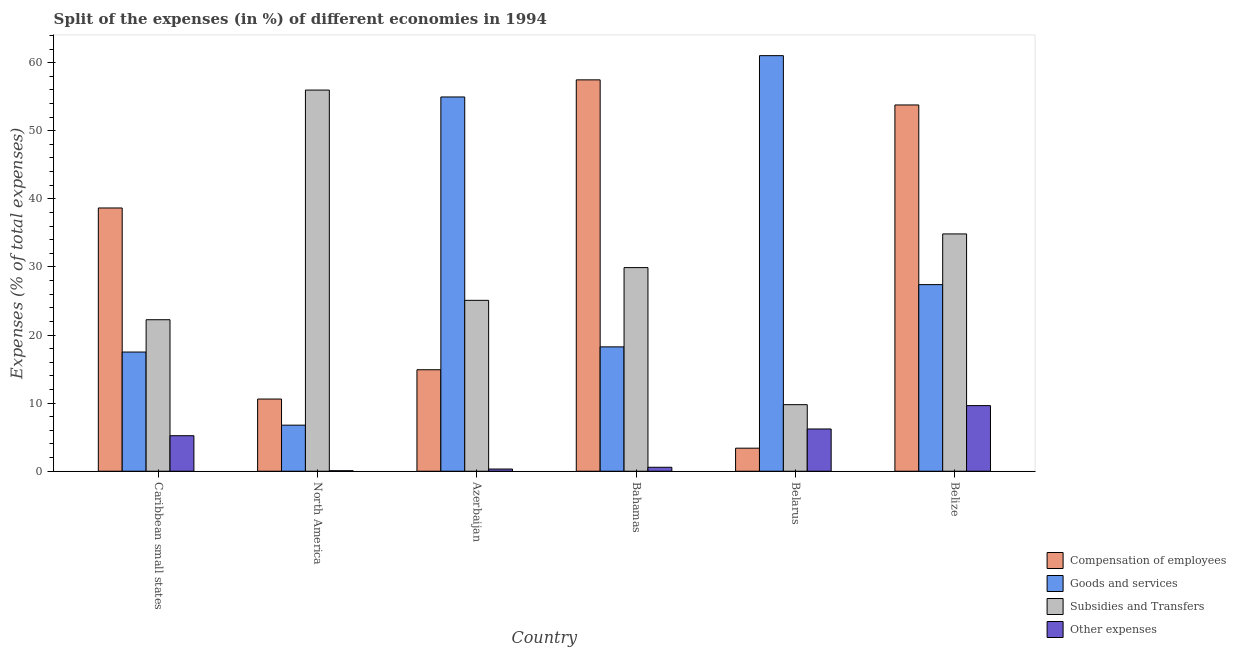How many bars are there on the 2nd tick from the left?
Your answer should be very brief. 4. What is the label of the 3rd group of bars from the left?
Your answer should be compact. Azerbaijan. What is the percentage of amount spent on subsidies in Caribbean small states?
Make the answer very short. 22.25. Across all countries, what is the maximum percentage of amount spent on subsidies?
Keep it short and to the point. 55.98. Across all countries, what is the minimum percentage of amount spent on other expenses?
Your response must be concise. 0.07. In which country was the percentage of amount spent on compensation of employees maximum?
Provide a short and direct response. Bahamas. In which country was the percentage of amount spent on subsidies minimum?
Ensure brevity in your answer.  Belarus. What is the total percentage of amount spent on goods and services in the graph?
Keep it short and to the point. 185.93. What is the difference between the percentage of amount spent on goods and services in Azerbaijan and that in Belize?
Your answer should be compact. 27.56. What is the difference between the percentage of amount spent on goods and services in Azerbaijan and the percentage of amount spent on compensation of employees in North America?
Provide a succinct answer. 44.36. What is the average percentage of amount spent on goods and services per country?
Keep it short and to the point. 30.99. What is the difference between the percentage of amount spent on other expenses and percentage of amount spent on compensation of employees in North America?
Offer a very short reply. -10.53. In how many countries, is the percentage of amount spent on other expenses greater than 54 %?
Make the answer very short. 0. What is the ratio of the percentage of amount spent on compensation of employees in Bahamas to that in Belarus?
Your answer should be very brief. 16.97. Is the difference between the percentage of amount spent on subsidies in Caribbean small states and North America greater than the difference between the percentage of amount spent on goods and services in Caribbean small states and North America?
Offer a terse response. No. What is the difference between the highest and the second highest percentage of amount spent on compensation of employees?
Keep it short and to the point. 3.69. What is the difference between the highest and the lowest percentage of amount spent on compensation of employees?
Make the answer very short. 54.09. In how many countries, is the percentage of amount spent on other expenses greater than the average percentage of amount spent on other expenses taken over all countries?
Offer a very short reply. 3. What does the 1st bar from the left in Bahamas represents?
Provide a short and direct response. Compensation of employees. What does the 3rd bar from the right in North America represents?
Keep it short and to the point. Goods and services. Is it the case that in every country, the sum of the percentage of amount spent on compensation of employees and percentage of amount spent on goods and services is greater than the percentage of amount spent on subsidies?
Ensure brevity in your answer.  No. How many bars are there?
Offer a terse response. 24. What is the difference between two consecutive major ticks on the Y-axis?
Your response must be concise. 10. Does the graph contain any zero values?
Keep it short and to the point. No. Does the graph contain grids?
Offer a terse response. No. How many legend labels are there?
Your answer should be compact. 4. How are the legend labels stacked?
Offer a very short reply. Vertical. What is the title of the graph?
Offer a very short reply. Split of the expenses (in %) of different economies in 1994. Does "Services" appear as one of the legend labels in the graph?
Provide a short and direct response. No. What is the label or title of the Y-axis?
Offer a very short reply. Expenses (% of total expenses). What is the Expenses (% of total expenses) of Compensation of employees in Caribbean small states?
Your answer should be compact. 38.66. What is the Expenses (% of total expenses) in Goods and services in Caribbean small states?
Your response must be concise. 17.5. What is the Expenses (% of total expenses) of Subsidies and Transfers in Caribbean small states?
Ensure brevity in your answer.  22.25. What is the Expenses (% of total expenses) of Other expenses in Caribbean small states?
Give a very brief answer. 5.22. What is the Expenses (% of total expenses) of Compensation of employees in North America?
Your answer should be compact. 10.6. What is the Expenses (% of total expenses) in Goods and services in North America?
Your answer should be very brief. 6.77. What is the Expenses (% of total expenses) in Subsidies and Transfers in North America?
Make the answer very short. 55.98. What is the Expenses (% of total expenses) of Other expenses in North America?
Provide a short and direct response. 0.07. What is the Expenses (% of total expenses) of Compensation of employees in Azerbaijan?
Your answer should be very brief. 14.9. What is the Expenses (% of total expenses) of Goods and services in Azerbaijan?
Give a very brief answer. 54.96. What is the Expenses (% of total expenses) of Subsidies and Transfers in Azerbaijan?
Your answer should be very brief. 25.1. What is the Expenses (% of total expenses) in Other expenses in Azerbaijan?
Your answer should be very brief. 0.32. What is the Expenses (% of total expenses) in Compensation of employees in Bahamas?
Offer a terse response. 57.48. What is the Expenses (% of total expenses) in Goods and services in Bahamas?
Provide a short and direct response. 18.26. What is the Expenses (% of total expenses) in Subsidies and Transfers in Bahamas?
Offer a very short reply. 29.9. What is the Expenses (% of total expenses) of Other expenses in Bahamas?
Ensure brevity in your answer.  0.58. What is the Expenses (% of total expenses) in Compensation of employees in Belarus?
Your answer should be compact. 3.39. What is the Expenses (% of total expenses) of Goods and services in Belarus?
Offer a terse response. 61.03. What is the Expenses (% of total expenses) of Subsidies and Transfers in Belarus?
Ensure brevity in your answer.  9.78. What is the Expenses (% of total expenses) in Other expenses in Belarus?
Your response must be concise. 6.21. What is the Expenses (% of total expenses) in Compensation of employees in Belize?
Ensure brevity in your answer.  53.79. What is the Expenses (% of total expenses) of Goods and services in Belize?
Keep it short and to the point. 27.41. What is the Expenses (% of total expenses) in Subsidies and Transfers in Belize?
Make the answer very short. 34.85. What is the Expenses (% of total expenses) of Other expenses in Belize?
Your response must be concise. 9.64. Across all countries, what is the maximum Expenses (% of total expenses) in Compensation of employees?
Offer a very short reply. 57.48. Across all countries, what is the maximum Expenses (% of total expenses) in Goods and services?
Your answer should be very brief. 61.03. Across all countries, what is the maximum Expenses (% of total expenses) in Subsidies and Transfers?
Offer a terse response. 55.98. Across all countries, what is the maximum Expenses (% of total expenses) in Other expenses?
Keep it short and to the point. 9.64. Across all countries, what is the minimum Expenses (% of total expenses) of Compensation of employees?
Give a very brief answer. 3.39. Across all countries, what is the minimum Expenses (% of total expenses) in Goods and services?
Offer a very short reply. 6.77. Across all countries, what is the minimum Expenses (% of total expenses) of Subsidies and Transfers?
Your answer should be compact. 9.78. Across all countries, what is the minimum Expenses (% of total expenses) in Other expenses?
Provide a short and direct response. 0.07. What is the total Expenses (% of total expenses) in Compensation of employees in the graph?
Provide a succinct answer. 178.82. What is the total Expenses (% of total expenses) of Goods and services in the graph?
Your response must be concise. 185.93. What is the total Expenses (% of total expenses) of Subsidies and Transfers in the graph?
Give a very brief answer. 177.85. What is the total Expenses (% of total expenses) in Other expenses in the graph?
Offer a very short reply. 22.04. What is the difference between the Expenses (% of total expenses) of Compensation of employees in Caribbean small states and that in North America?
Make the answer very short. 28.06. What is the difference between the Expenses (% of total expenses) of Goods and services in Caribbean small states and that in North America?
Give a very brief answer. 10.74. What is the difference between the Expenses (% of total expenses) of Subsidies and Transfers in Caribbean small states and that in North America?
Give a very brief answer. -33.73. What is the difference between the Expenses (% of total expenses) of Other expenses in Caribbean small states and that in North America?
Provide a succinct answer. 5.14. What is the difference between the Expenses (% of total expenses) in Compensation of employees in Caribbean small states and that in Azerbaijan?
Provide a succinct answer. 23.76. What is the difference between the Expenses (% of total expenses) of Goods and services in Caribbean small states and that in Azerbaijan?
Provide a succinct answer. -37.46. What is the difference between the Expenses (% of total expenses) of Subsidies and Transfers in Caribbean small states and that in Azerbaijan?
Give a very brief answer. -2.85. What is the difference between the Expenses (% of total expenses) in Other expenses in Caribbean small states and that in Azerbaijan?
Keep it short and to the point. 4.89. What is the difference between the Expenses (% of total expenses) in Compensation of employees in Caribbean small states and that in Bahamas?
Keep it short and to the point. -18.82. What is the difference between the Expenses (% of total expenses) of Goods and services in Caribbean small states and that in Bahamas?
Your response must be concise. -0.76. What is the difference between the Expenses (% of total expenses) of Subsidies and Transfers in Caribbean small states and that in Bahamas?
Keep it short and to the point. -7.65. What is the difference between the Expenses (% of total expenses) of Other expenses in Caribbean small states and that in Bahamas?
Make the answer very short. 4.63. What is the difference between the Expenses (% of total expenses) in Compensation of employees in Caribbean small states and that in Belarus?
Give a very brief answer. 35.27. What is the difference between the Expenses (% of total expenses) in Goods and services in Caribbean small states and that in Belarus?
Keep it short and to the point. -43.53. What is the difference between the Expenses (% of total expenses) in Subsidies and Transfers in Caribbean small states and that in Belarus?
Your response must be concise. 12.47. What is the difference between the Expenses (% of total expenses) of Other expenses in Caribbean small states and that in Belarus?
Give a very brief answer. -0.99. What is the difference between the Expenses (% of total expenses) of Compensation of employees in Caribbean small states and that in Belize?
Make the answer very short. -15.13. What is the difference between the Expenses (% of total expenses) in Goods and services in Caribbean small states and that in Belize?
Your answer should be very brief. -9.9. What is the difference between the Expenses (% of total expenses) in Subsidies and Transfers in Caribbean small states and that in Belize?
Offer a terse response. -12.6. What is the difference between the Expenses (% of total expenses) of Other expenses in Caribbean small states and that in Belize?
Provide a succinct answer. -4.42. What is the difference between the Expenses (% of total expenses) of Compensation of employees in North America and that in Azerbaijan?
Offer a very short reply. -4.3. What is the difference between the Expenses (% of total expenses) of Goods and services in North America and that in Azerbaijan?
Your answer should be compact. -48.2. What is the difference between the Expenses (% of total expenses) of Subsidies and Transfers in North America and that in Azerbaijan?
Keep it short and to the point. 30.88. What is the difference between the Expenses (% of total expenses) in Other expenses in North America and that in Azerbaijan?
Your answer should be compact. -0.25. What is the difference between the Expenses (% of total expenses) of Compensation of employees in North America and that in Bahamas?
Offer a very short reply. -46.87. What is the difference between the Expenses (% of total expenses) of Goods and services in North America and that in Bahamas?
Provide a short and direct response. -11.5. What is the difference between the Expenses (% of total expenses) of Subsidies and Transfers in North America and that in Bahamas?
Your answer should be compact. 26.07. What is the difference between the Expenses (% of total expenses) of Other expenses in North America and that in Bahamas?
Ensure brevity in your answer.  -0.51. What is the difference between the Expenses (% of total expenses) of Compensation of employees in North America and that in Belarus?
Make the answer very short. 7.22. What is the difference between the Expenses (% of total expenses) of Goods and services in North America and that in Belarus?
Your answer should be very brief. -54.26. What is the difference between the Expenses (% of total expenses) of Subsidies and Transfers in North America and that in Belarus?
Make the answer very short. 46.2. What is the difference between the Expenses (% of total expenses) of Other expenses in North America and that in Belarus?
Provide a succinct answer. -6.13. What is the difference between the Expenses (% of total expenses) in Compensation of employees in North America and that in Belize?
Offer a very short reply. -43.19. What is the difference between the Expenses (% of total expenses) of Goods and services in North America and that in Belize?
Give a very brief answer. -20.64. What is the difference between the Expenses (% of total expenses) of Subsidies and Transfers in North America and that in Belize?
Offer a terse response. 21.13. What is the difference between the Expenses (% of total expenses) of Other expenses in North America and that in Belize?
Give a very brief answer. -9.56. What is the difference between the Expenses (% of total expenses) in Compensation of employees in Azerbaijan and that in Bahamas?
Your answer should be compact. -42.57. What is the difference between the Expenses (% of total expenses) in Goods and services in Azerbaijan and that in Bahamas?
Keep it short and to the point. 36.7. What is the difference between the Expenses (% of total expenses) of Subsidies and Transfers in Azerbaijan and that in Bahamas?
Offer a terse response. -4.81. What is the difference between the Expenses (% of total expenses) in Other expenses in Azerbaijan and that in Bahamas?
Your answer should be very brief. -0.26. What is the difference between the Expenses (% of total expenses) of Compensation of employees in Azerbaijan and that in Belarus?
Give a very brief answer. 11.52. What is the difference between the Expenses (% of total expenses) of Goods and services in Azerbaijan and that in Belarus?
Offer a terse response. -6.07. What is the difference between the Expenses (% of total expenses) in Subsidies and Transfers in Azerbaijan and that in Belarus?
Offer a very short reply. 15.32. What is the difference between the Expenses (% of total expenses) in Other expenses in Azerbaijan and that in Belarus?
Ensure brevity in your answer.  -5.88. What is the difference between the Expenses (% of total expenses) in Compensation of employees in Azerbaijan and that in Belize?
Offer a terse response. -38.89. What is the difference between the Expenses (% of total expenses) of Goods and services in Azerbaijan and that in Belize?
Keep it short and to the point. 27.56. What is the difference between the Expenses (% of total expenses) in Subsidies and Transfers in Azerbaijan and that in Belize?
Your answer should be compact. -9.75. What is the difference between the Expenses (% of total expenses) in Other expenses in Azerbaijan and that in Belize?
Ensure brevity in your answer.  -9.31. What is the difference between the Expenses (% of total expenses) in Compensation of employees in Bahamas and that in Belarus?
Your answer should be compact. 54.09. What is the difference between the Expenses (% of total expenses) of Goods and services in Bahamas and that in Belarus?
Keep it short and to the point. -42.77. What is the difference between the Expenses (% of total expenses) of Subsidies and Transfers in Bahamas and that in Belarus?
Make the answer very short. 20.13. What is the difference between the Expenses (% of total expenses) in Other expenses in Bahamas and that in Belarus?
Your answer should be very brief. -5.62. What is the difference between the Expenses (% of total expenses) of Compensation of employees in Bahamas and that in Belize?
Ensure brevity in your answer.  3.69. What is the difference between the Expenses (% of total expenses) in Goods and services in Bahamas and that in Belize?
Provide a short and direct response. -9.14. What is the difference between the Expenses (% of total expenses) of Subsidies and Transfers in Bahamas and that in Belize?
Offer a terse response. -4.94. What is the difference between the Expenses (% of total expenses) in Other expenses in Bahamas and that in Belize?
Keep it short and to the point. -9.05. What is the difference between the Expenses (% of total expenses) of Compensation of employees in Belarus and that in Belize?
Provide a short and direct response. -50.4. What is the difference between the Expenses (% of total expenses) in Goods and services in Belarus and that in Belize?
Provide a short and direct response. 33.62. What is the difference between the Expenses (% of total expenses) in Subsidies and Transfers in Belarus and that in Belize?
Your response must be concise. -25.07. What is the difference between the Expenses (% of total expenses) of Other expenses in Belarus and that in Belize?
Make the answer very short. -3.43. What is the difference between the Expenses (% of total expenses) in Compensation of employees in Caribbean small states and the Expenses (% of total expenses) in Goods and services in North America?
Offer a terse response. 31.89. What is the difference between the Expenses (% of total expenses) in Compensation of employees in Caribbean small states and the Expenses (% of total expenses) in Subsidies and Transfers in North America?
Offer a very short reply. -17.32. What is the difference between the Expenses (% of total expenses) of Compensation of employees in Caribbean small states and the Expenses (% of total expenses) of Other expenses in North America?
Your response must be concise. 38.58. What is the difference between the Expenses (% of total expenses) in Goods and services in Caribbean small states and the Expenses (% of total expenses) in Subsidies and Transfers in North America?
Your answer should be compact. -38.47. What is the difference between the Expenses (% of total expenses) in Goods and services in Caribbean small states and the Expenses (% of total expenses) in Other expenses in North America?
Keep it short and to the point. 17.43. What is the difference between the Expenses (% of total expenses) of Subsidies and Transfers in Caribbean small states and the Expenses (% of total expenses) of Other expenses in North America?
Offer a very short reply. 22.18. What is the difference between the Expenses (% of total expenses) in Compensation of employees in Caribbean small states and the Expenses (% of total expenses) in Goods and services in Azerbaijan?
Give a very brief answer. -16.3. What is the difference between the Expenses (% of total expenses) in Compensation of employees in Caribbean small states and the Expenses (% of total expenses) in Subsidies and Transfers in Azerbaijan?
Make the answer very short. 13.56. What is the difference between the Expenses (% of total expenses) of Compensation of employees in Caribbean small states and the Expenses (% of total expenses) of Other expenses in Azerbaijan?
Offer a very short reply. 38.34. What is the difference between the Expenses (% of total expenses) in Goods and services in Caribbean small states and the Expenses (% of total expenses) in Subsidies and Transfers in Azerbaijan?
Your response must be concise. -7.59. What is the difference between the Expenses (% of total expenses) of Goods and services in Caribbean small states and the Expenses (% of total expenses) of Other expenses in Azerbaijan?
Your answer should be very brief. 17.18. What is the difference between the Expenses (% of total expenses) in Subsidies and Transfers in Caribbean small states and the Expenses (% of total expenses) in Other expenses in Azerbaijan?
Your answer should be compact. 21.93. What is the difference between the Expenses (% of total expenses) of Compensation of employees in Caribbean small states and the Expenses (% of total expenses) of Goods and services in Bahamas?
Offer a very short reply. 20.4. What is the difference between the Expenses (% of total expenses) in Compensation of employees in Caribbean small states and the Expenses (% of total expenses) in Subsidies and Transfers in Bahamas?
Your answer should be very brief. 8.76. What is the difference between the Expenses (% of total expenses) of Compensation of employees in Caribbean small states and the Expenses (% of total expenses) of Other expenses in Bahamas?
Ensure brevity in your answer.  38.08. What is the difference between the Expenses (% of total expenses) of Goods and services in Caribbean small states and the Expenses (% of total expenses) of Subsidies and Transfers in Bahamas?
Your answer should be compact. -12.4. What is the difference between the Expenses (% of total expenses) of Goods and services in Caribbean small states and the Expenses (% of total expenses) of Other expenses in Bahamas?
Provide a succinct answer. 16.92. What is the difference between the Expenses (% of total expenses) in Subsidies and Transfers in Caribbean small states and the Expenses (% of total expenses) in Other expenses in Bahamas?
Offer a terse response. 21.67. What is the difference between the Expenses (% of total expenses) in Compensation of employees in Caribbean small states and the Expenses (% of total expenses) in Goods and services in Belarus?
Your answer should be very brief. -22.37. What is the difference between the Expenses (% of total expenses) of Compensation of employees in Caribbean small states and the Expenses (% of total expenses) of Subsidies and Transfers in Belarus?
Offer a terse response. 28.88. What is the difference between the Expenses (% of total expenses) of Compensation of employees in Caribbean small states and the Expenses (% of total expenses) of Other expenses in Belarus?
Offer a terse response. 32.45. What is the difference between the Expenses (% of total expenses) of Goods and services in Caribbean small states and the Expenses (% of total expenses) of Subsidies and Transfers in Belarus?
Offer a very short reply. 7.73. What is the difference between the Expenses (% of total expenses) in Goods and services in Caribbean small states and the Expenses (% of total expenses) in Other expenses in Belarus?
Provide a short and direct response. 11.3. What is the difference between the Expenses (% of total expenses) of Subsidies and Transfers in Caribbean small states and the Expenses (% of total expenses) of Other expenses in Belarus?
Provide a succinct answer. 16.04. What is the difference between the Expenses (% of total expenses) of Compensation of employees in Caribbean small states and the Expenses (% of total expenses) of Goods and services in Belize?
Give a very brief answer. 11.25. What is the difference between the Expenses (% of total expenses) in Compensation of employees in Caribbean small states and the Expenses (% of total expenses) in Subsidies and Transfers in Belize?
Provide a short and direct response. 3.81. What is the difference between the Expenses (% of total expenses) of Compensation of employees in Caribbean small states and the Expenses (% of total expenses) of Other expenses in Belize?
Give a very brief answer. 29.02. What is the difference between the Expenses (% of total expenses) in Goods and services in Caribbean small states and the Expenses (% of total expenses) in Subsidies and Transfers in Belize?
Your answer should be compact. -17.34. What is the difference between the Expenses (% of total expenses) of Goods and services in Caribbean small states and the Expenses (% of total expenses) of Other expenses in Belize?
Offer a terse response. 7.87. What is the difference between the Expenses (% of total expenses) of Subsidies and Transfers in Caribbean small states and the Expenses (% of total expenses) of Other expenses in Belize?
Make the answer very short. 12.61. What is the difference between the Expenses (% of total expenses) in Compensation of employees in North America and the Expenses (% of total expenses) in Goods and services in Azerbaijan?
Your response must be concise. -44.36. What is the difference between the Expenses (% of total expenses) of Compensation of employees in North America and the Expenses (% of total expenses) of Subsidies and Transfers in Azerbaijan?
Make the answer very short. -14.49. What is the difference between the Expenses (% of total expenses) of Compensation of employees in North America and the Expenses (% of total expenses) of Other expenses in Azerbaijan?
Offer a terse response. 10.28. What is the difference between the Expenses (% of total expenses) of Goods and services in North America and the Expenses (% of total expenses) of Subsidies and Transfers in Azerbaijan?
Offer a terse response. -18.33. What is the difference between the Expenses (% of total expenses) in Goods and services in North America and the Expenses (% of total expenses) in Other expenses in Azerbaijan?
Your answer should be compact. 6.44. What is the difference between the Expenses (% of total expenses) in Subsidies and Transfers in North America and the Expenses (% of total expenses) in Other expenses in Azerbaijan?
Your answer should be very brief. 55.65. What is the difference between the Expenses (% of total expenses) of Compensation of employees in North America and the Expenses (% of total expenses) of Goods and services in Bahamas?
Your response must be concise. -7.66. What is the difference between the Expenses (% of total expenses) of Compensation of employees in North America and the Expenses (% of total expenses) of Subsidies and Transfers in Bahamas?
Your response must be concise. -19.3. What is the difference between the Expenses (% of total expenses) of Compensation of employees in North America and the Expenses (% of total expenses) of Other expenses in Bahamas?
Your response must be concise. 10.02. What is the difference between the Expenses (% of total expenses) in Goods and services in North America and the Expenses (% of total expenses) in Subsidies and Transfers in Bahamas?
Your answer should be very brief. -23.14. What is the difference between the Expenses (% of total expenses) in Goods and services in North America and the Expenses (% of total expenses) in Other expenses in Bahamas?
Your answer should be very brief. 6.18. What is the difference between the Expenses (% of total expenses) in Subsidies and Transfers in North America and the Expenses (% of total expenses) in Other expenses in Bahamas?
Your answer should be very brief. 55.39. What is the difference between the Expenses (% of total expenses) of Compensation of employees in North America and the Expenses (% of total expenses) of Goods and services in Belarus?
Keep it short and to the point. -50.43. What is the difference between the Expenses (% of total expenses) in Compensation of employees in North America and the Expenses (% of total expenses) in Subsidies and Transfers in Belarus?
Keep it short and to the point. 0.83. What is the difference between the Expenses (% of total expenses) of Compensation of employees in North America and the Expenses (% of total expenses) of Other expenses in Belarus?
Offer a terse response. 4.4. What is the difference between the Expenses (% of total expenses) of Goods and services in North America and the Expenses (% of total expenses) of Subsidies and Transfers in Belarus?
Make the answer very short. -3.01. What is the difference between the Expenses (% of total expenses) of Goods and services in North America and the Expenses (% of total expenses) of Other expenses in Belarus?
Give a very brief answer. 0.56. What is the difference between the Expenses (% of total expenses) in Subsidies and Transfers in North America and the Expenses (% of total expenses) in Other expenses in Belarus?
Your response must be concise. 49.77. What is the difference between the Expenses (% of total expenses) of Compensation of employees in North America and the Expenses (% of total expenses) of Goods and services in Belize?
Offer a terse response. -16.8. What is the difference between the Expenses (% of total expenses) of Compensation of employees in North America and the Expenses (% of total expenses) of Subsidies and Transfers in Belize?
Offer a terse response. -24.25. What is the difference between the Expenses (% of total expenses) in Compensation of employees in North America and the Expenses (% of total expenses) in Other expenses in Belize?
Offer a terse response. 0.97. What is the difference between the Expenses (% of total expenses) in Goods and services in North America and the Expenses (% of total expenses) in Subsidies and Transfers in Belize?
Keep it short and to the point. -28.08. What is the difference between the Expenses (% of total expenses) of Goods and services in North America and the Expenses (% of total expenses) of Other expenses in Belize?
Offer a terse response. -2.87. What is the difference between the Expenses (% of total expenses) of Subsidies and Transfers in North America and the Expenses (% of total expenses) of Other expenses in Belize?
Offer a terse response. 46.34. What is the difference between the Expenses (% of total expenses) of Compensation of employees in Azerbaijan and the Expenses (% of total expenses) of Goods and services in Bahamas?
Offer a very short reply. -3.36. What is the difference between the Expenses (% of total expenses) in Compensation of employees in Azerbaijan and the Expenses (% of total expenses) in Subsidies and Transfers in Bahamas?
Provide a short and direct response. -15. What is the difference between the Expenses (% of total expenses) of Compensation of employees in Azerbaijan and the Expenses (% of total expenses) of Other expenses in Bahamas?
Your answer should be compact. 14.32. What is the difference between the Expenses (% of total expenses) of Goods and services in Azerbaijan and the Expenses (% of total expenses) of Subsidies and Transfers in Bahamas?
Keep it short and to the point. 25.06. What is the difference between the Expenses (% of total expenses) in Goods and services in Azerbaijan and the Expenses (% of total expenses) in Other expenses in Bahamas?
Ensure brevity in your answer.  54.38. What is the difference between the Expenses (% of total expenses) of Subsidies and Transfers in Azerbaijan and the Expenses (% of total expenses) of Other expenses in Bahamas?
Make the answer very short. 24.52. What is the difference between the Expenses (% of total expenses) of Compensation of employees in Azerbaijan and the Expenses (% of total expenses) of Goods and services in Belarus?
Provide a succinct answer. -46.13. What is the difference between the Expenses (% of total expenses) of Compensation of employees in Azerbaijan and the Expenses (% of total expenses) of Subsidies and Transfers in Belarus?
Provide a succinct answer. 5.13. What is the difference between the Expenses (% of total expenses) of Compensation of employees in Azerbaijan and the Expenses (% of total expenses) of Other expenses in Belarus?
Your answer should be very brief. 8.7. What is the difference between the Expenses (% of total expenses) in Goods and services in Azerbaijan and the Expenses (% of total expenses) in Subsidies and Transfers in Belarus?
Offer a terse response. 45.19. What is the difference between the Expenses (% of total expenses) of Goods and services in Azerbaijan and the Expenses (% of total expenses) of Other expenses in Belarus?
Offer a very short reply. 48.76. What is the difference between the Expenses (% of total expenses) of Subsidies and Transfers in Azerbaijan and the Expenses (% of total expenses) of Other expenses in Belarus?
Your response must be concise. 18.89. What is the difference between the Expenses (% of total expenses) in Compensation of employees in Azerbaijan and the Expenses (% of total expenses) in Goods and services in Belize?
Give a very brief answer. -12.5. What is the difference between the Expenses (% of total expenses) of Compensation of employees in Azerbaijan and the Expenses (% of total expenses) of Subsidies and Transfers in Belize?
Provide a short and direct response. -19.95. What is the difference between the Expenses (% of total expenses) in Compensation of employees in Azerbaijan and the Expenses (% of total expenses) in Other expenses in Belize?
Offer a very short reply. 5.27. What is the difference between the Expenses (% of total expenses) of Goods and services in Azerbaijan and the Expenses (% of total expenses) of Subsidies and Transfers in Belize?
Make the answer very short. 20.11. What is the difference between the Expenses (% of total expenses) of Goods and services in Azerbaijan and the Expenses (% of total expenses) of Other expenses in Belize?
Your answer should be very brief. 45.33. What is the difference between the Expenses (% of total expenses) of Subsidies and Transfers in Azerbaijan and the Expenses (% of total expenses) of Other expenses in Belize?
Your answer should be very brief. 15.46. What is the difference between the Expenses (% of total expenses) in Compensation of employees in Bahamas and the Expenses (% of total expenses) in Goods and services in Belarus?
Offer a very short reply. -3.55. What is the difference between the Expenses (% of total expenses) of Compensation of employees in Bahamas and the Expenses (% of total expenses) of Subsidies and Transfers in Belarus?
Your answer should be compact. 47.7. What is the difference between the Expenses (% of total expenses) of Compensation of employees in Bahamas and the Expenses (% of total expenses) of Other expenses in Belarus?
Provide a short and direct response. 51.27. What is the difference between the Expenses (% of total expenses) of Goods and services in Bahamas and the Expenses (% of total expenses) of Subsidies and Transfers in Belarus?
Your answer should be compact. 8.49. What is the difference between the Expenses (% of total expenses) in Goods and services in Bahamas and the Expenses (% of total expenses) in Other expenses in Belarus?
Ensure brevity in your answer.  12.06. What is the difference between the Expenses (% of total expenses) of Subsidies and Transfers in Bahamas and the Expenses (% of total expenses) of Other expenses in Belarus?
Ensure brevity in your answer.  23.7. What is the difference between the Expenses (% of total expenses) of Compensation of employees in Bahamas and the Expenses (% of total expenses) of Goods and services in Belize?
Your response must be concise. 30.07. What is the difference between the Expenses (% of total expenses) in Compensation of employees in Bahamas and the Expenses (% of total expenses) in Subsidies and Transfers in Belize?
Your response must be concise. 22.63. What is the difference between the Expenses (% of total expenses) of Compensation of employees in Bahamas and the Expenses (% of total expenses) of Other expenses in Belize?
Ensure brevity in your answer.  47.84. What is the difference between the Expenses (% of total expenses) of Goods and services in Bahamas and the Expenses (% of total expenses) of Subsidies and Transfers in Belize?
Ensure brevity in your answer.  -16.58. What is the difference between the Expenses (% of total expenses) in Goods and services in Bahamas and the Expenses (% of total expenses) in Other expenses in Belize?
Provide a succinct answer. 8.63. What is the difference between the Expenses (% of total expenses) of Subsidies and Transfers in Bahamas and the Expenses (% of total expenses) of Other expenses in Belize?
Keep it short and to the point. 20.27. What is the difference between the Expenses (% of total expenses) of Compensation of employees in Belarus and the Expenses (% of total expenses) of Goods and services in Belize?
Provide a short and direct response. -24.02. What is the difference between the Expenses (% of total expenses) of Compensation of employees in Belarus and the Expenses (% of total expenses) of Subsidies and Transfers in Belize?
Ensure brevity in your answer.  -31.46. What is the difference between the Expenses (% of total expenses) of Compensation of employees in Belarus and the Expenses (% of total expenses) of Other expenses in Belize?
Offer a very short reply. -6.25. What is the difference between the Expenses (% of total expenses) in Goods and services in Belarus and the Expenses (% of total expenses) in Subsidies and Transfers in Belize?
Your response must be concise. 26.18. What is the difference between the Expenses (% of total expenses) in Goods and services in Belarus and the Expenses (% of total expenses) in Other expenses in Belize?
Offer a very short reply. 51.39. What is the difference between the Expenses (% of total expenses) in Subsidies and Transfers in Belarus and the Expenses (% of total expenses) in Other expenses in Belize?
Provide a short and direct response. 0.14. What is the average Expenses (% of total expenses) in Compensation of employees per country?
Keep it short and to the point. 29.8. What is the average Expenses (% of total expenses) in Goods and services per country?
Your answer should be very brief. 30.99. What is the average Expenses (% of total expenses) of Subsidies and Transfers per country?
Give a very brief answer. 29.64. What is the average Expenses (% of total expenses) in Other expenses per country?
Offer a terse response. 3.67. What is the difference between the Expenses (% of total expenses) of Compensation of employees and Expenses (% of total expenses) of Goods and services in Caribbean small states?
Your response must be concise. 21.16. What is the difference between the Expenses (% of total expenses) in Compensation of employees and Expenses (% of total expenses) in Subsidies and Transfers in Caribbean small states?
Make the answer very short. 16.41. What is the difference between the Expenses (% of total expenses) of Compensation of employees and Expenses (% of total expenses) of Other expenses in Caribbean small states?
Ensure brevity in your answer.  33.44. What is the difference between the Expenses (% of total expenses) in Goods and services and Expenses (% of total expenses) in Subsidies and Transfers in Caribbean small states?
Your answer should be very brief. -4.75. What is the difference between the Expenses (% of total expenses) of Goods and services and Expenses (% of total expenses) of Other expenses in Caribbean small states?
Provide a short and direct response. 12.29. What is the difference between the Expenses (% of total expenses) in Subsidies and Transfers and Expenses (% of total expenses) in Other expenses in Caribbean small states?
Make the answer very short. 17.03. What is the difference between the Expenses (% of total expenses) of Compensation of employees and Expenses (% of total expenses) of Goods and services in North America?
Offer a very short reply. 3.84. What is the difference between the Expenses (% of total expenses) in Compensation of employees and Expenses (% of total expenses) in Subsidies and Transfers in North America?
Keep it short and to the point. -45.37. What is the difference between the Expenses (% of total expenses) in Compensation of employees and Expenses (% of total expenses) in Other expenses in North America?
Your answer should be very brief. 10.53. What is the difference between the Expenses (% of total expenses) in Goods and services and Expenses (% of total expenses) in Subsidies and Transfers in North America?
Provide a short and direct response. -49.21. What is the difference between the Expenses (% of total expenses) of Goods and services and Expenses (% of total expenses) of Other expenses in North America?
Ensure brevity in your answer.  6.69. What is the difference between the Expenses (% of total expenses) of Subsidies and Transfers and Expenses (% of total expenses) of Other expenses in North America?
Provide a succinct answer. 55.9. What is the difference between the Expenses (% of total expenses) of Compensation of employees and Expenses (% of total expenses) of Goods and services in Azerbaijan?
Your answer should be compact. -40.06. What is the difference between the Expenses (% of total expenses) of Compensation of employees and Expenses (% of total expenses) of Subsidies and Transfers in Azerbaijan?
Provide a succinct answer. -10.19. What is the difference between the Expenses (% of total expenses) of Compensation of employees and Expenses (% of total expenses) of Other expenses in Azerbaijan?
Your answer should be compact. 14.58. What is the difference between the Expenses (% of total expenses) in Goods and services and Expenses (% of total expenses) in Subsidies and Transfers in Azerbaijan?
Your answer should be compact. 29.87. What is the difference between the Expenses (% of total expenses) in Goods and services and Expenses (% of total expenses) in Other expenses in Azerbaijan?
Your answer should be compact. 54.64. What is the difference between the Expenses (% of total expenses) in Subsidies and Transfers and Expenses (% of total expenses) in Other expenses in Azerbaijan?
Your answer should be very brief. 24.77. What is the difference between the Expenses (% of total expenses) in Compensation of employees and Expenses (% of total expenses) in Goods and services in Bahamas?
Offer a terse response. 39.21. What is the difference between the Expenses (% of total expenses) in Compensation of employees and Expenses (% of total expenses) in Subsidies and Transfers in Bahamas?
Make the answer very short. 27.57. What is the difference between the Expenses (% of total expenses) of Compensation of employees and Expenses (% of total expenses) of Other expenses in Bahamas?
Offer a very short reply. 56.89. What is the difference between the Expenses (% of total expenses) of Goods and services and Expenses (% of total expenses) of Subsidies and Transfers in Bahamas?
Your answer should be very brief. -11.64. What is the difference between the Expenses (% of total expenses) of Goods and services and Expenses (% of total expenses) of Other expenses in Bahamas?
Your answer should be compact. 17.68. What is the difference between the Expenses (% of total expenses) of Subsidies and Transfers and Expenses (% of total expenses) of Other expenses in Bahamas?
Offer a very short reply. 29.32. What is the difference between the Expenses (% of total expenses) of Compensation of employees and Expenses (% of total expenses) of Goods and services in Belarus?
Offer a very short reply. -57.64. What is the difference between the Expenses (% of total expenses) in Compensation of employees and Expenses (% of total expenses) in Subsidies and Transfers in Belarus?
Keep it short and to the point. -6.39. What is the difference between the Expenses (% of total expenses) of Compensation of employees and Expenses (% of total expenses) of Other expenses in Belarus?
Provide a succinct answer. -2.82. What is the difference between the Expenses (% of total expenses) in Goods and services and Expenses (% of total expenses) in Subsidies and Transfers in Belarus?
Provide a succinct answer. 51.25. What is the difference between the Expenses (% of total expenses) of Goods and services and Expenses (% of total expenses) of Other expenses in Belarus?
Ensure brevity in your answer.  54.82. What is the difference between the Expenses (% of total expenses) in Subsidies and Transfers and Expenses (% of total expenses) in Other expenses in Belarus?
Ensure brevity in your answer.  3.57. What is the difference between the Expenses (% of total expenses) in Compensation of employees and Expenses (% of total expenses) in Goods and services in Belize?
Make the answer very short. 26.38. What is the difference between the Expenses (% of total expenses) of Compensation of employees and Expenses (% of total expenses) of Subsidies and Transfers in Belize?
Ensure brevity in your answer.  18.94. What is the difference between the Expenses (% of total expenses) of Compensation of employees and Expenses (% of total expenses) of Other expenses in Belize?
Offer a terse response. 44.15. What is the difference between the Expenses (% of total expenses) of Goods and services and Expenses (% of total expenses) of Subsidies and Transfers in Belize?
Provide a succinct answer. -7.44. What is the difference between the Expenses (% of total expenses) of Goods and services and Expenses (% of total expenses) of Other expenses in Belize?
Ensure brevity in your answer.  17.77. What is the difference between the Expenses (% of total expenses) of Subsidies and Transfers and Expenses (% of total expenses) of Other expenses in Belize?
Make the answer very short. 25.21. What is the ratio of the Expenses (% of total expenses) in Compensation of employees in Caribbean small states to that in North America?
Your answer should be compact. 3.65. What is the ratio of the Expenses (% of total expenses) in Goods and services in Caribbean small states to that in North America?
Offer a terse response. 2.59. What is the ratio of the Expenses (% of total expenses) of Subsidies and Transfers in Caribbean small states to that in North America?
Your answer should be very brief. 0.4. What is the ratio of the Expenses (% of total expenses) in Other expenses in Caribbean small states to that in North America?
Provide a succinct answer. 69.91. What is the ratio of the Expenses (% of total expenses) of Compensation of employees in Caribbean small states to that in Azerbaijan?
Keep it short and to the point. 2.59. What is the ratio of the Expenses (% of total expenses) of Goods and services in Caribbean small states to that in Azerbaijan?
Your answer should be compact. 0.32. What is the ratio of the Expenses (% of total expenses) in Subsidies and Transfers in Caribbean small states to that in Azerbaijan?
Your answer should be compact. 0.89. What is the ratio of the Expenses (% of total expenses) of Other expenses in Caribbean small states to that in Azerbaijan?
Ensure brevity in your answer.  16.18. What is the ratio of the Expenses (% of total expenses) in Compensation of employees in Caribbean small states to that in Bahamas?
Your response must be concise. 0.67. What is the ratio of the Expenses (% of total expenses) in Goods and services in Caribbean small states to that in Bahamas?
Keep it short and to the point. 0.96. What is the ratio of the Expenses (% of total expenses) of Subsidies and Transfers in Caribbean small states to that in Bahamas?
Offer a very short reply. 0.74. What is the ratio of the Expenses (% of total expenses) in Other expenses in Caribbean small states to that in Bahamas?
Provide a succinct answer. 8.97. What is the ratio of the Expenses (% of total expenses) in Compensation of employees in Caribbean small states to that in Belarus?
Give a very brief answer. 11.42. What is the ratio of the Expenses (% of total expenses) in Goods and services in Caribbean small states to that in Belarus?
Ensure brevity in your answer.  0.29. What is the ratio of the Expenses (% of total expenses) in Subsidies and Transfers in Caribbean small states to that in Belarus?
Provide a succinct answer. 2.28. What is the ratio of the Expenses (% of total expenses) in Other expenses in Caribbean small states to that in Belarus?
Provide a succinct answer. 0.84. What is the ratio of the Expenses (% of total expenses) of Compensation of employees in Caribbean small states to that in Belize?
Your response must be concise. 0.72. What is the ratio of the Expenses (% of total expenses) of Goods and services in Caribbean small states to that in Belize?
Make the answer very short. 0.64. What is the ratio of the Expenses (% of total expenses) of Subsidies and Transfers in Caribbean small states to that in Belize?
Keep it short and to the point. 0.64. What is the ratio of the Expenses (% of total expenses) in Other expenses in Caribbean small states to that in Belize?
Offer a very short reply. 0.54. What is the ratio of the Expenses (% of total expenses) in Compensation of employees in North America to that in Azerbaijan?
Keep it short and to the point. 0.71. What is the ratio of the Expenses (% of total expenses) of Goods and services in North America to that in Azerbaijan?
Ensure brevity in your answer.  0.12. What is the ratio of the Expenses (% of total expenses) of Subsidies and Transfers in North America to that in Azerbaijan?
Your answer should be very brief. 2.23. What is the ratio of the Expenses (% of total expenses) of Other expenses in North America to that in Azerbaijan?
Provide a short and direct response. 0.23. What is the ratio of the Expenses (% of total expenses) of Compensation of employees in North America to that in Bahamas?
Ensure brevity in your answer.  0.18. What is the ratio of the Expenses (% of total expenses) of Goods and services in North America to that in Bahamas?
Give a very brief answer. 0.37. What is the ratio of the Expenses (% of total expenses) of Subsidies and Transfers in North America to that in Bahamas?
Give a very brief answer. 1.87. What is the ratio of the Expenses (% of total expenses) of Other expenses in North America to that in Bahamas?
Give a very brief answer. 0.13. What is the ratio of the Expenses (% of total expenses) of Compensation of employees in North America to that in Belarus?
Make the answer very short. 3.13. What is the ratio of the Expenses (% of total expenses) of Goods and services in North America to that in Belarus?
Your answer should be compact. 0.11. What is the ratio of the Expenses (% of total expenses) in Subsidies and Transfers in North America to that in Belarus?
Provide a succinct answer. 5.73. What is the ratio of the Expenses (% of total expenses) in Other expenses in North America to that in Belarus?
Your answer should be very brief. 0.01. What is the ratio of the Expenses (% of total expenses) in Compensation of employees in North America to that in Belize?
Provide a short and direct response. 0.2. What is the ratio of the Expenses (% of total expenses) in Goods and services in North America to that in Belize?
Offer a terse response. 0.25. What is the ratio of the Expenses (% of total expenses) in Subsidies and Transfers in North America to that in Belize?
Make the answer very short. 1.61. What is the ratio of the Expenses (% of total expenses) in Other expenses in North America to that in Belize?
Provide a succinct answer. 0.01. What is the ratio of the Expenses (% of total expenses) in Compensation of employees in Azerbaijan to that in Bahamas?
Give a very brief answer. 0.26. What is the ratio of the Expenses (% of total expenses) in Goods and services in Azerbaijan to that in Bahamas?
Offer a very short reply. 3.01. What is the ratio of the Expenses (% of total expenses) of Subsidies and Transfers in Azerbaijan to that in Bahamas?
Your answer should be very brief. 0.84. What is the ratio of the Expenses (% of total expenses) in Other expenses in Azerbaijan to that in Bahamas?
Your answer should be very brief. 0.55. What is the ratio of the Expenses (% of total expenses) in Compensation of employees in Azerbaijan to that in Belarus?
Your answer should be very brief. 4.4. What is the ratio of the Expenses (% of total expenses) of Goods and services in Azerbaijan to that in Belarus?
Your answer should be very brief. 0.9. What is the ratio of the Expenses (% of total expenses) of Subsidies and Transfers in Azerbaijan to that in Belarus?
Offer a terse response. 2.57. What is the ratio of the Expenses (% of total expenses) of Other expenses in Azerbaijan to that in Belarus?
Provide a succinct answer. 0.05. What is the ratio of the Expenses (% of total expenses) in Compensation of employees in Azerbaijan to that in Belize?
Your response must be concise. 0.28. What is the ratio of the Expenses (% of total expenses) in Goods and services in Azerbaijan to that in Belize?
Offer a terse response. 2.01. What is the ratio of the Expenses (% of total expenses) in Subsidies and Transfers in Azerbaijan to that in Belize?
Keep it short and to the point. 0.72. What is the ratio of the Expenses (% of total expenses) in Other expenses in Azerbaijan to that in Belize?
Keep it short and to the point. 0.03. What is the ratio of the Expenses (% of total expenses) in Compensation of employees in Bahamas to that in Belarus?
Provide a short and direct response. 16.97. What is the ratio of the Expenses (% of total expenses) in Goods and services in Bahamas to that in Belarus?
Ensure brevity in your answer.  0.3. What is the ratio of the Expenses (% of total expenses) of Subsidies and Transfers in Bahamas to that in Belarus?
Make the answer very short. 3.06. What is the ratio of the Expenses (% of total expenses) in Other expenses in Bahamas to that in Belarus?
Provide a succinct answer. 0.09. What is the ratio of the Expenses (% of total expenses) in Compensation of employees in Bahamas to that in Belize?
Ensure brevity in your answer.  1.07. What is the ratio of the Expenses (% of total expenses) in Goods and services in Bahamas to that in Belize?
Your response must be concise. 0.67. What is the ratio of the Expenses (% of total expenses) of Subsidies and Transfers in Bahamas to that in Belize?
Give a very brief answer. 0.86. What is the ratio of the Expenses (% of total expenses) of Other expenses in Bahamas to that in Belize?
Provide a succinct answer. 0.06. What is the ratio of the Expenses (% of total expenses) in Compensation of employees in Belarus to that in Belize?
Your response must be concise. 0.06. What is the ratio of the Expenses (% of total expenses) in Goods and services in Belarus to that in Belize?
Ensure brevity in your answer.  2.23. What is the ratio of the Expenses (% of total expenses) of Subsidies and Transfers in Belarus to that in Belize?
Your answer should be compact. 0.28. What is the ratio of the Expenses (% of total expenses) of Other expenses in Belarus to that in Belize?
Offer a very short reply. 0.64. What is the difference between the highest and the second highest Expenses (% of total expenses) in Compensation of employees?
Offer a terse response. 3.69. What is the difference between the highest and the second highest Expenses (% of total expenses) of Goods and services?
Make the answer very short. 6.07. What is the difference between the highest and the second highest Expenses (% of total expenses) in Subsidies and Transfers?
Keep it short and to the point. 21.13. What is the difference between the highest and the second highest Expenses (% of total expenses) of Other expenses?
Keep it short and to the point. 3.43. What is the difference between the highest and the lowest Expenses (% of total expenses) of Compensation of employees?
Your answer should be compact. 54.09. What is the difference between the highest and the lowest Expenses (% of total expenses) in Goods and services?
Your answer should be compact. 54.26. What is the difference between the highest and the lowest Expenses (% of total expenses) of Subsidies and Transfers?
Make the answer very short. 46.2. What is the difference between the highest and the lowest Expenses (% of total expenses) in Other expenses?
Provide a succinct answer. 9.56. 